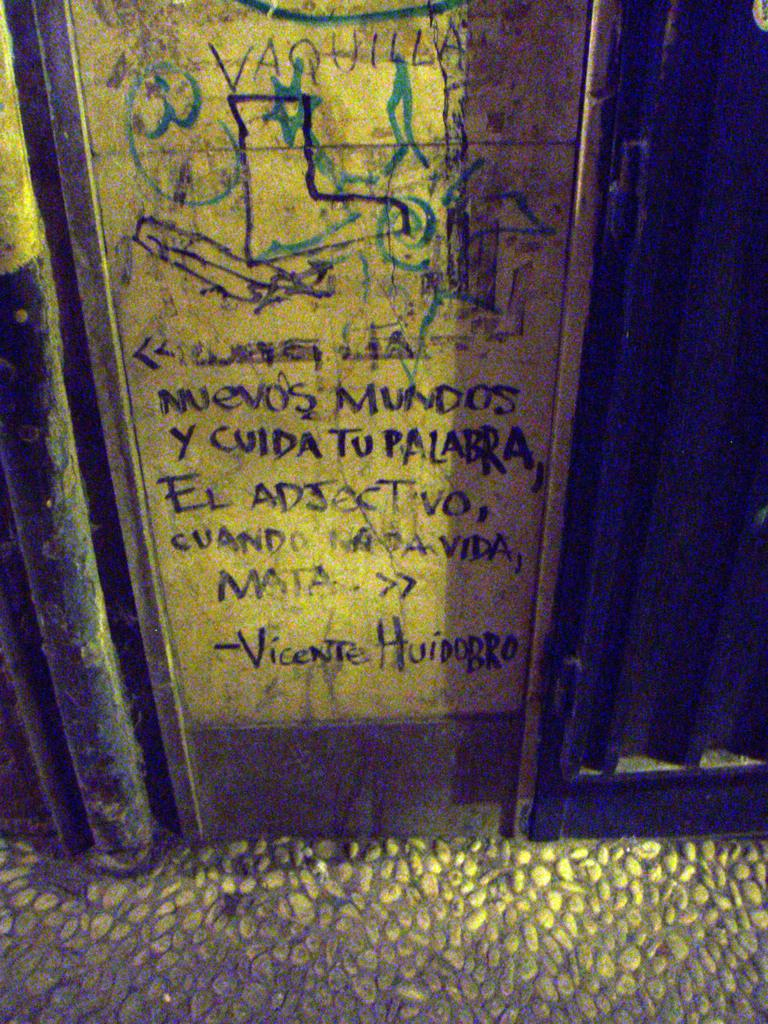<image>
Present a compact description of the photo's key features. A wall covered in graffiti in Spanish seemingly signed by Vicente Huidorro. 